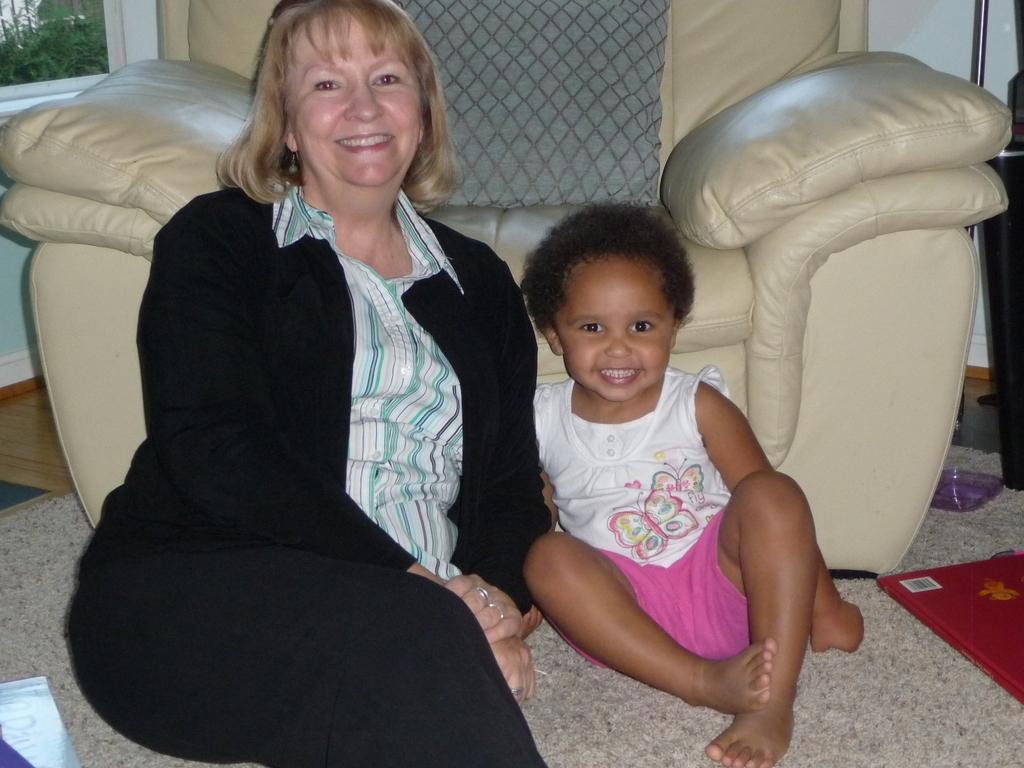Who is present in the image? There is a woman in the image. What is the woman wearing? The woman is wearing a suit. Where is the woman sitting? The woman is sitting on the floor. What else can be seen in the image? There is a baby in the image, and they are beside the woman. What is the location of the baby in relation to the woman? The baby is beside the woman. What piece of furniture is in the image? There is a recliner in the image. Where are the woman and baby in relation to the recliner? The woman and baby are in front of the recliner. What is visible on the wall in the image? There is a window on the wall. What is behind the window? There are plants behind the window. What type of owl can be seen flying through the fog in the image? There is no owl or fog present in the image. 